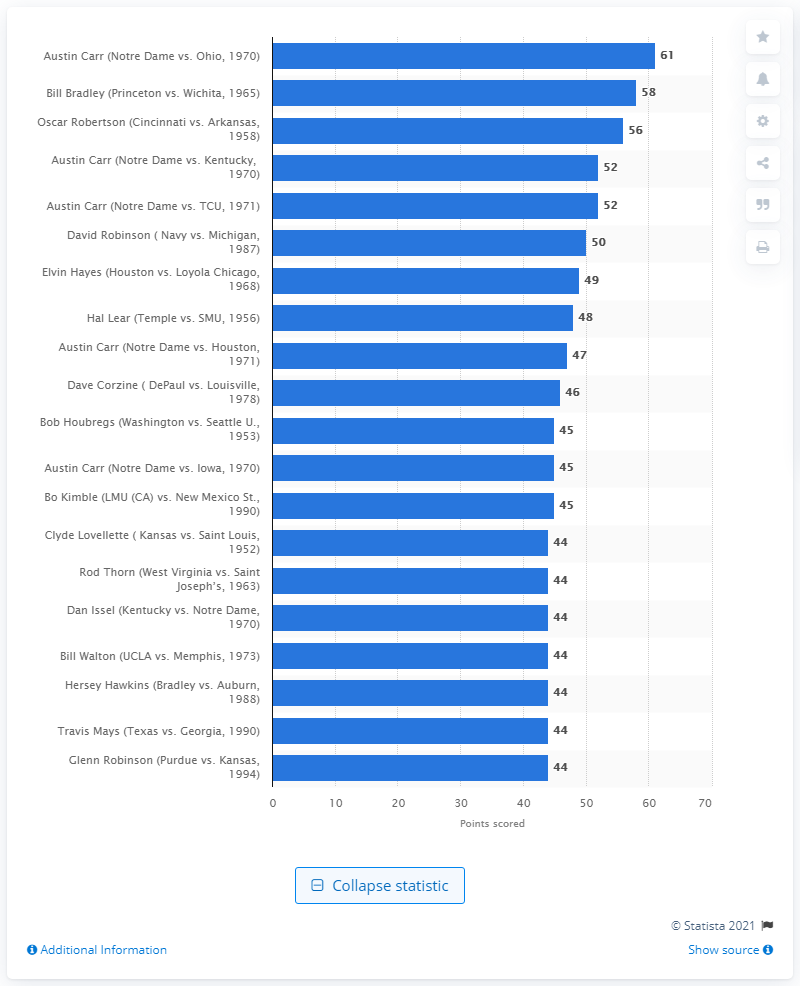Give some essential details in this illustration. In the first round of March Madness, Austin Carr scored a remarkable 61 points against Ohio, cementing his place as a basketball legend. 